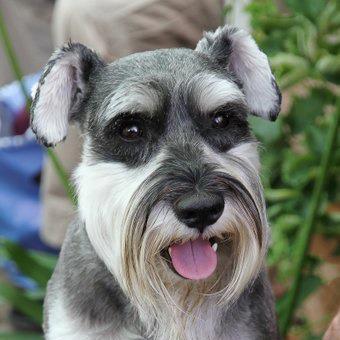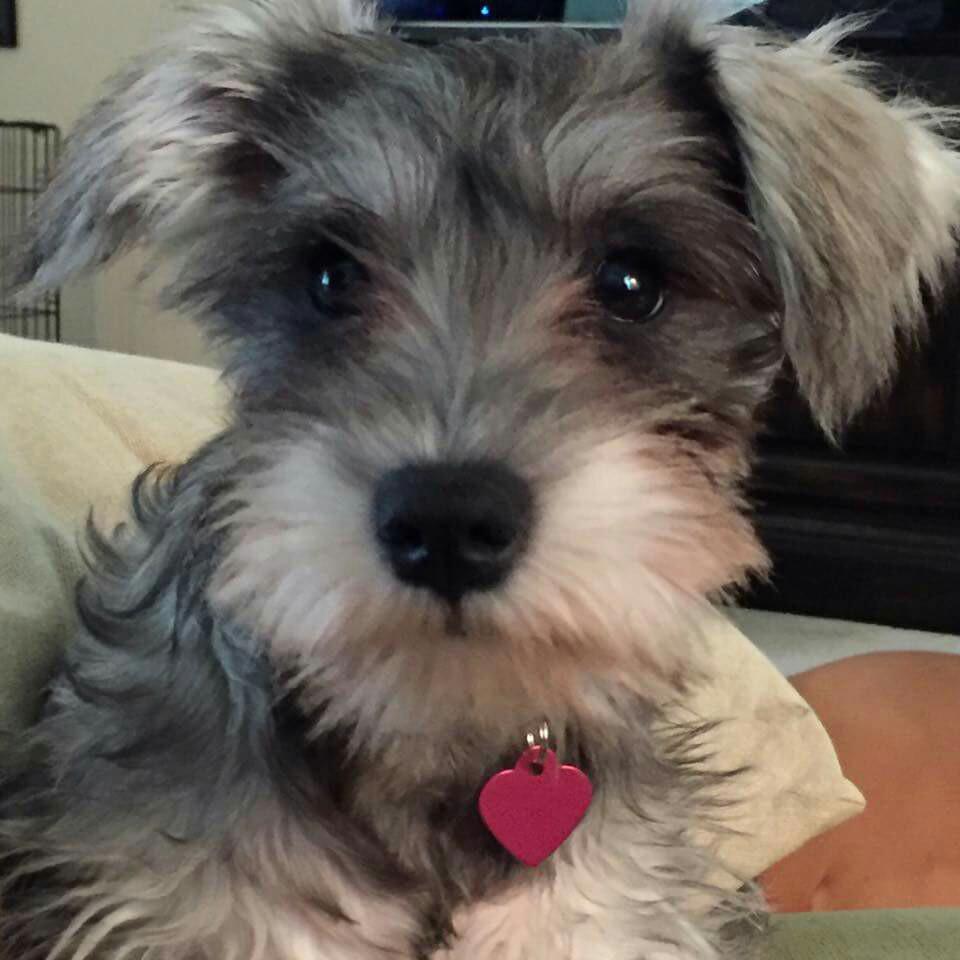The first image is the image on the left, the second image is the image on the right. Evaluate the accuracy of this statement regarding the images: "The left image contains at least two dogs.". Is it true? Answer yes or no. No. The first image is the image on the left, the second image is the image on the right. Considering the images on both sides, is "Each image contains one forward-facing schnauzer, and one image features a dog with a tag charm dangling under its chin." valid? Answer yes or no. Yes. 